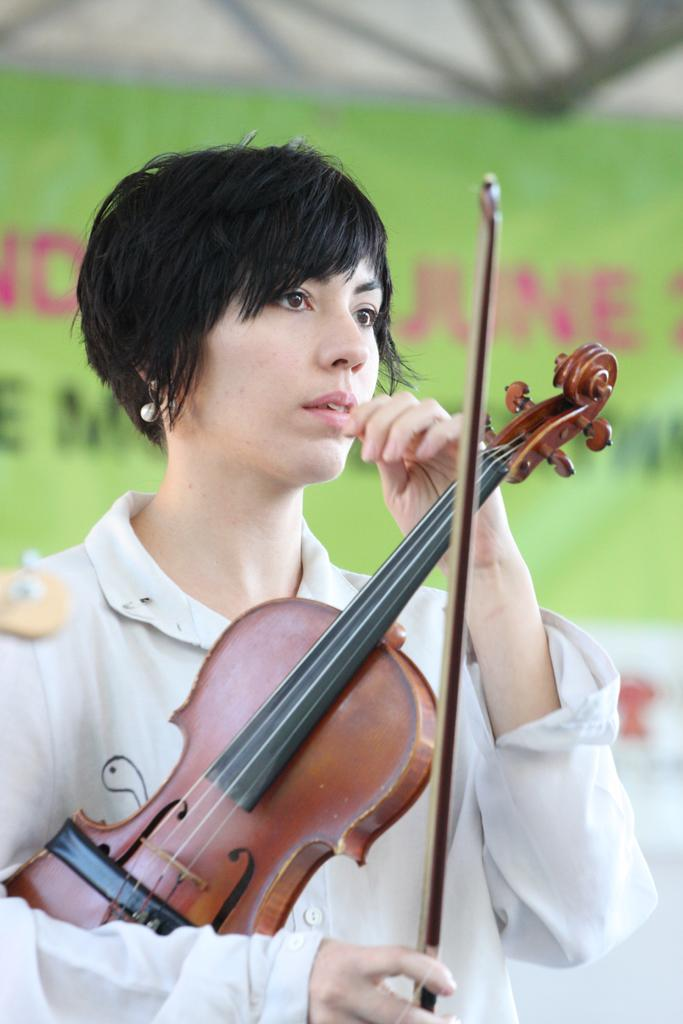Who is the person in the image? There is a woman in the image. What is the woman wearing? The woman is wearing a white dress. What is the woman holding in the image? The woman is holding a violin. What can be seen in the background of the image? There is a green color banner in the image. What is written on the banner? The banner has something written on it, but we cannot determine the exact text from the image. What type of nose can be seen on the woman in the image? There is no nose visible on the woman in the image, as the image only shows her from the shoulders up. What type of underwear is the woman wearing in the image? There is no information about the woman's underwear in the image, as it only shows her from the shoulders up. 